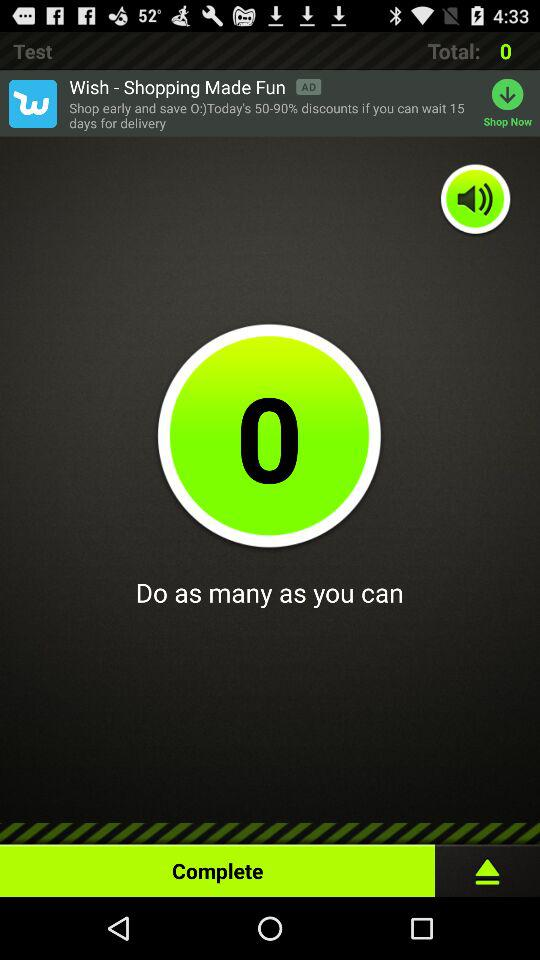How many items are in the cart?
Answer the question using a single word or phrase. 0 